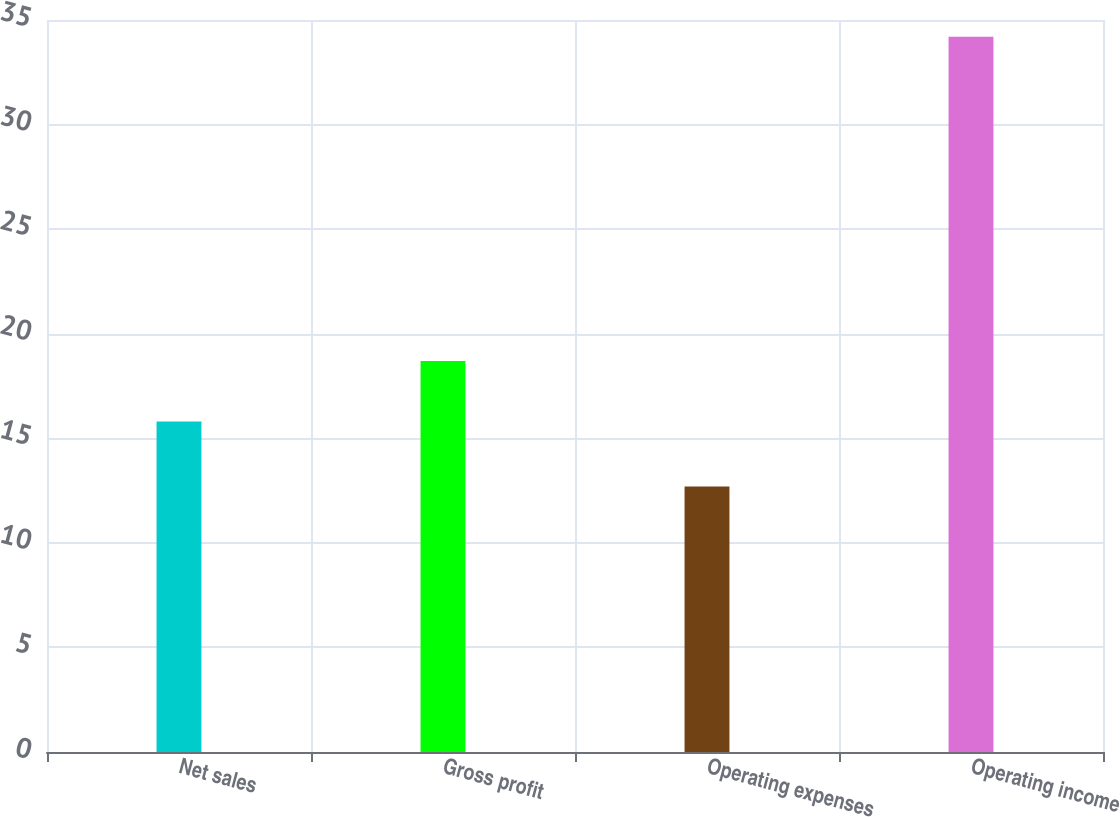<chart> <loc_0><loc_0><loc_500><loc_500><bar_chart><fcel>Net sales<fcel>Gross profit<fcel>Operating expenses<fcel>Operating income<nl><fcel>15.8<fcel>18.7<fcel>12.7<fcel>34.2<nl></chart> 